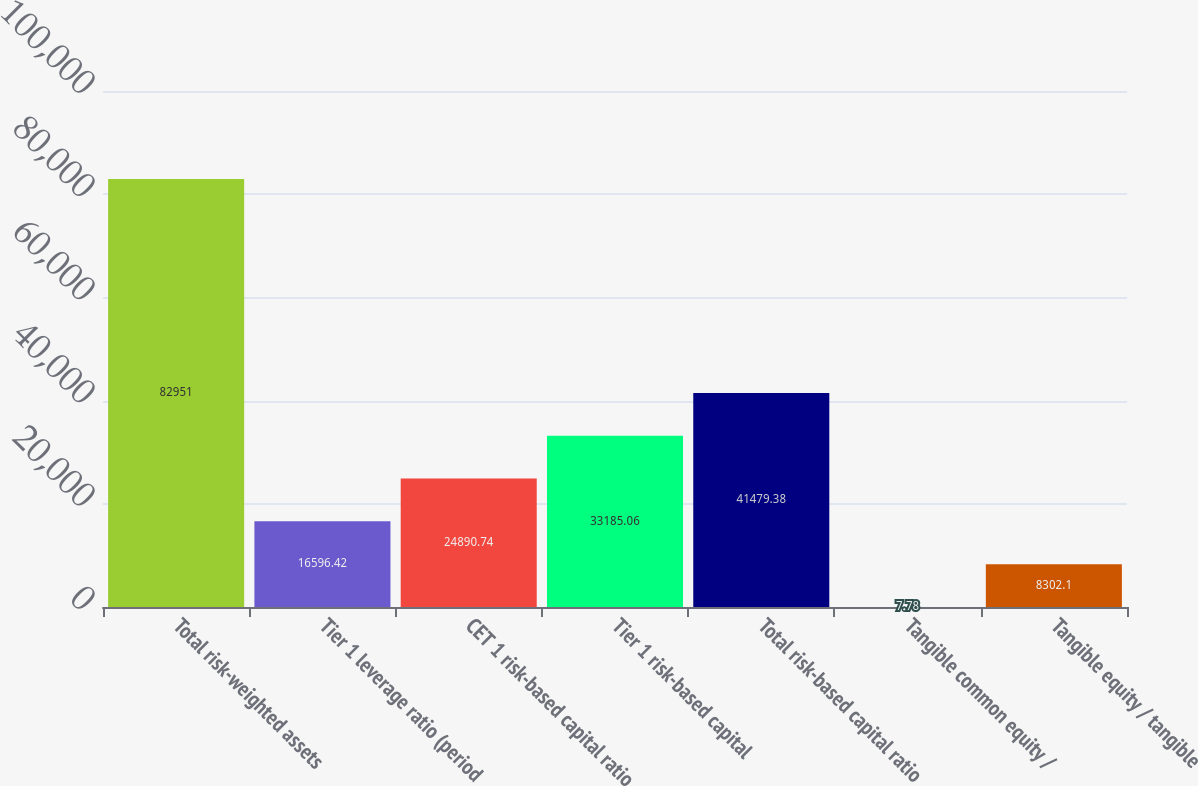<chart> <loc_0><loc_0><loc_500><loc_500><bar_chart><fcel>Total risk-weighted assets<fcel>Tier 1 leverage ratio (period<fcel>CET 1 risk-based capital ratio<fcel>Tier 1 risk-based capital<fcel>Total risk-based capital ratio<fcel>Tangible common equity /<fcel>Tangible equity / tangible<nl><fcel>82951<fcel>16596.4<fcel>24890.7<fcel>33185.1<fcel>41479.4<fcel>7.78<fcel>8302.1<nl></chart> 